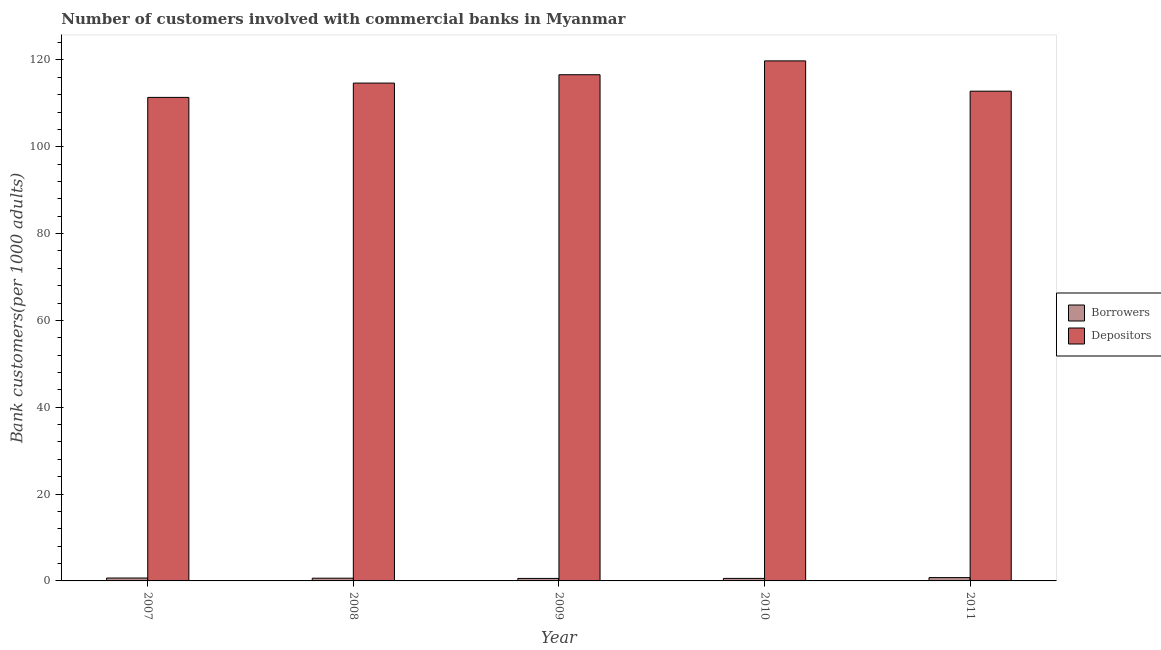How many different coloured bars are there?
Your answer should be compact. 2. How many groups of bars are there?
Provide a succinct answer. 5. How many bars are there on the 4th tick from the right?
Ensure brevity in your answer.  2. What is the label of the 5th group of bars from the left?
Provide a short and direct response. 2011. In how many cases, is the number of bars for a given year not equal to the number of legend labels?
Offer a very short reply. 0. What is the number of depositors in 2011?
Offer a very short reply. 112.8. Across all years, what is the maximum number of depositors?
Give a very brief answer. 119.78. Across all years, what is the minimum number of depositors?
Offer a terse response. 111.37. In which year was the number of depositors maximum?
Offer a very short reply. 2010. In which year was the number of borrowers minimum?
Make the answer very short. 2009. What is the total number of depositors in the graph?
Provide a short and direct response. 575.2. What is the difference between the number of borrowers in 2010 and that in 2011?
Give a very brief answer. -0.18. What is the difference between the number of depositors in 2010 and the number of borrowers in 2007?
Make the answer very short. 8.41. What is the average number of borrowers per year?
Your response must be concise. 0.64. What is the ratio of the number of depositors in 2007 to that in 2008?
Your answer should be compact. 0.97. What is the difference between the highest and the second highest number of borrowers?
Provide a short and direct response. 0.1. What is the difference between the highest and the lowest number of depositors?
Your answer should be compact. 8.41. Is the sum of the number of borrowers in 2007 and 2010 greater than the maximum number of depositors across all years?
Your answer should be compact. Yes. What does the 2nd bar from the left in 2011 represents?
Your answer should be very brief. Depositors. What does the 2nd bar from the right in 2010 represents?
Provide a short and direct response. Borrowers. What is the difference between two consecutive major ticks on the Y-axis?
Make the answer very short. 20. Does the graph contain any zero values?
Offer a very short reply. No. Where does the legend appear in the graph?
Keep it short and to the point. Center right. How many legend labels are there?
Provide a short and direct response. 2. How are the legend labels stacked?
Make the answer very short. Vertical. What is the title of the graph?
Offer a very short reply. Number of customers involved with commercial banks in Myanmar. Does "Foreign Liabilities" appear as one of the legend labels in the graph?
Keep it short and to the point. No. What is the label or title of the X-axis?
Your answer should be very brief. Year. What is the label or title of the Y-axis?
Give a very brief answer. Bank customers(per 1000 adults). What is the Bank customers(per 1000 adults) of Borrowers in 2007?
Ensure brevity in your answer.  0.67. What is the Bank customers(per 1000 adults) in Depositors in 2007?
Provide a succinct answer. 111.37. What is the Bank customers(per 1000 adults) of Borrowers in 2008?
Provide a succinct answer. 0.63. What is the Bank customers(per 1000 adults) in Depositors in 2008?
Offer a very short reply. 114.66. What is the Bank customers(per 1000 adults) in Borrowers in 2009?
Offer a terse response. 0.58. What is the Bank customers(per 1000 adults) in Depositors in 2009?
Provide a succinct answer. 116.59. What is the Bank customers(per 1000 adults) of Borrowers in 2010?
Provide a short and direct response. 0.58. What is the Bank customers(per 1000 adults) of Depositors in 2010?
Provide a short and direct response. 119.78. What is the Bank customers(per 1000 adults) of Borrowers in 2011?
Provide a succinct answer. 0.76. What is the Bank customers(per 1000 adults) in Depositors in 2011?
Offer a terse response. 112.8. Across all years, what is the maximum Bank customers(per 1000 adults) of Borrowers?
Keep it short and to the point. 0.76. Across all years, what is the maximum Bank customers(per 1000 adults) in Depositors?
Give a very brief answer. 119.78. Across all years, what is the minimum Bank customers(per 1000 adults) in Borrowers?
Offer a terse response. 0.58. Across all years, what is the minimum Bank customers(per 1000 adults) in Depositors?
Your response must be concise. 111.37. What is the total Bank customers(per 1000 adults) of Borrowers in the graph?
Offer a terse response. 3.22. What is the total Bank customers(per 1000 adults) of Depositors in the graph?
Your answer should be very brief. 575.2. What is the difference between the Bank customers(per 1000 adults) of Borrowers in 2007 and that in 2008?
Give a very brief answer. 0.04. What is the difference between the Bank customers(per 1000 adults) of Depositors in 2007 and that in 2008?
Offer a very short reply. -3.3. What is the difference between the Bank customers(per 1000 adults) in Borrowers in 2007 and that in 2009?
Ensure brevity in your answer.  0.09. What is the difference between the Bank customers(per 1000 adults) in Depositors in 2007 and that in 2009?
Your answer should be compact. -5.22. What is the difference between the Bank customers(per 1000 adults) in Borrowers in 2007 and that in 2010?
Offer a terse response. 0.09. What is the difference between the Bank customers(per 1000 adults) of Depositors in 2007 and that in 2010?
Provide a short and direct response. -8.41. What is the difference between the Bank customers(per 1000 adults) of Borrowers in 2007 and that in 2011?
Keep it short and to the point. -0.1. What is the difference between the Bank customers(per 1000 adults) in Depositors in 2007 and that in 2011?
Give a very brief answer. -1.43. What is the difference between the Bank customers(per 1000 adults) of Borrowers in 2008 and that in 2009?
Give a very brief answer. 0.05. What is the difference between the Bank customers(per 1000 adults) of Depositors in 2008 and that in 2009?
Make the answer very short. -1.92. What is the difference between the Bank customers(per 1000 adults) of Borrowers in 2008 and that in 2010?
Ensure brevity in your answer.  0.04. What is the difference between the Bank customers(per 1000 adults) in Depositors in 2008 and that in 2010?
Provide a short and direct response. -5.11. What is the difference between the Bank customers(per 1000 adults) in Borrowers in 2008 and that in 2011?
Offer a terse response. -0.14. What is the difference between the Bank customers(per 1000 adults) in Depositors in 2008 and that in 2011?
Offer a terse response. 1.86. What is the difference between the Bank customers(per 1000 adults) of Borrowers in 2009 and that in 2010?
Offer a very short reply. -0. What is the difference between the Bank customers(per 1000 adults) in Depositors in 2009 and that in 2010?
Provide a succinct answer. -3.19. What is the difference between the Bank customers(per 1000 adults) of Borrowers in 2009 and that in 2011?
Your answer should be very brief. -0.19. What is the difference between the Bank customers(per 1000 adults) of Depositors in 2009 and that in 2011?
Your response must be concise. 3.79. What is the difference between the Bank customers(per 1000 adults) of Borrowers in 2010 and that in 2011?
Your answer should be compact. -0.18. What is the difference between the Bank customers(per 1000 adults) in Depositors in 2010 and that in 2011?
Provide a short and direct response. 6.98. What is the difference between the Bank customers(per 1000 adults) in Borrowers in 2007 and the Bank customers(per 1000 adults) in Depositors in 2008?
Provide a succinct answer. -114. What is the difference between the Bank customers(per 1000 adults) of Borrowers in 2007 and the Bank customers(per 1000 adults) of Depositors in 2009?
Keep it short and to the point. -115.92. What is the difference between the Bank customers(per 1000 adults) in Borrowers in 2007 and the Bank customers(per 1000 adults) in Depositors in 2010?
Provide a short and direct response. -119.11. What is the difference between the Bank customers(per 1000 adults) in Borrowers in 2007 and the Bank customers(per 1000 adults) in Depositors in 2011?
Your answer should be very brief. -112.13. What is the difference between the Bank customers(per 1000 adults) in Borrowers in 2008 and the Bank customers(per 1000 adults) in Depositors in 2009?
Your answer should be compact. -115.96. What is the difference between the Bank customers(per 1000 adults) in Borrowers in 2008 and the Bank customers(per 1000 adults) in Depositors in 2010?
Keep it short and to the point. -119.15. What is the difference between the Bank customers(per 1000 adults) of Borrowers in 2008 and the Bank customers(per 1000 adults) of Depositors in 2011?
Your answer should be compact. -112.17. What is the difference between the Bank customers(per 1000 adults) in Borrowers in 2009 and the Bank customers(per 1000 adults) in Depositors in 2010?
Give a very brief answer. -119.2. What is the difference between the Bank customers(per 1000 adults) in Borrowers in 2009 and the Bank customers(per 1000 adults) in Depositors in 2011?
Ensure brevity in your answer.  -112.22. What is the difference between the Bank customers(per 1000 adults) of Borrowers in 2010 and the Bank customers(per 1000 adults) of Depositors in 2011?
Make the answer very short. -112.22. What is the average Bank customers(per 1000 adults) of Borrowers per year?
Offer a very short reply. 0.64. What is the average Bank customers(per 1000 adults) of Depositors per year?
Give a very brief answer. 115.04. In the year 2007, what is the difference between the Bank customers(per 1000 adults) in Borrowers and Bank customers(per 1000 adults) in Depositors?
Your answer should be very brief. -110.7. In the year 2008, what is the difference between the Bank customers(per 1000 adults) of Borrowers and Bank customers(per 1000 adults) of Depositors?
Keep it short and to the point. -114.04. In the year 2009, what is the difference between the Bank customers(per 1000 adults) in Borrowers and Bank customers(per 1000 adults) in Depositors?
Provide a succinct answer. -116.01. In the year 2010, what is the difference between the Bank customers(per 1000 adults) of Borrowers and Bank customers(per 1000 adults) of Depositors?
Give a very brief answer. -119.2. In the year 2011, what is the difference between the Bank customers(per 1000 adults) in Borrowers and Bank customers(per 1000 adults) in Depositors?
Ensure brevity in your answer.  -112.04. What is the ratio of the Bank customers(per 1000 adults) in Borrowers in 2007 to that in 2008?
Your answer should be very brief. 1.07. What is the ratio of the Bank customers(per 1000 adults) of Depositors in 2007 to that in 2008?
Your response must be concise. 0.97. What is the ratio of the Bank customers(per 1000 adults) in Borrowers in 2007 to that in 2009?
Provide a succinct answer. 1.16. What is the ratio of the Bank customers(per 1000 adults) in Depositors in 2007 to that in 2009?
Give a very brief answer. 0.96. What is the ratio of the Bank customers(per 1000 adults) in Borrowers in 2007 to that in 2010?
Ensure brevity in your answer.  1.15. What is the ratio of the Bank customers(per 1000 adults) of Depositors in 2007 to that in 2010?
Keep it short and to the point. 0.93. What is the ratio of the Bank customers(per 1000 adults) of Borrowers in 2007 to that in 2011?
Your answer should be very brief. 0.87. What is the ratio of the Bank customers(per 1000 adults) of Depositors in 2007 to that in 2011?
Your answer should be compact. 0.99. What is the ratio of the Bank customers(per 1000 adults) in Borrowers in 2008 to that in 2009?
Offer a terse response. 1.08. What is the ratio of the Bank customers(per 1000 adults) in Depositors in 2008 to that in 2009?
Keep it short and to the point. 0.98. What is the ratio of the Bank customers(per 1000 adults) in Borrowers in 2008 to that in 2010?
Offer a terse response. 1.08. What is the ratio of the Bank customers(per 1000 adults) in Depositors in 2008 to that in 2010?
Your response must be concise. 0.96. What is the ratio of the Bank customers(per 1000 adults) in Borrowers in 2008 to that in 2011?
Provide a short and direct response. 0.82. What is the ratio of the Bank customers(per 1000 adults) of Depositors in 2008 to that in 2011?
Keep it short and to the point. 1.02. What is the ratio of the Bank customers(per 1000 adults) of Depositors in 2009 to that in 2010?
Make the answer very short. 0.97. What is the ratio of the Bank customers(per 1000 adults) in Borrowers in 2009 to that in 2011?
Keep it short and to the point. 0.76. What is the ratio of the Bank customers(per 1000 adults) of Depositors in 2009 to that in 2011?
Keep it short and to the point. 1.03. What is the ratio of the Bank customers(per 1000 adults) in Borrowers in 2010 to that in 2011?
Provide a short and direct response. 0.76. What is the ratio of the Bank customers(per 1000 adults) of Depositors in 2010 to that in 2011?
Give a very brief answer. 1.06. What is the difference between the highest and the second highest Bank customers(per 1000 adults) of Borrowers?
Ensure brevity in your answer.  0.1. What is the difference between the highest and the second highest Bank customers(per 1000 adults) in Depositors?
Keep it short and to the point. 3.19. What is the difference between the highest and the lowest Bank customers(per 1000 adults) of Borrowers?
Make the answer very short. 0.19. What is the difference between the highest and the lowest Bank customers(per 1000 adults) of Depositors?
Give a very brief answer. 8.41. 